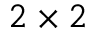<formula> <loc_0><loc_0><loc_500><loc_500>2 \times 2</formula> 